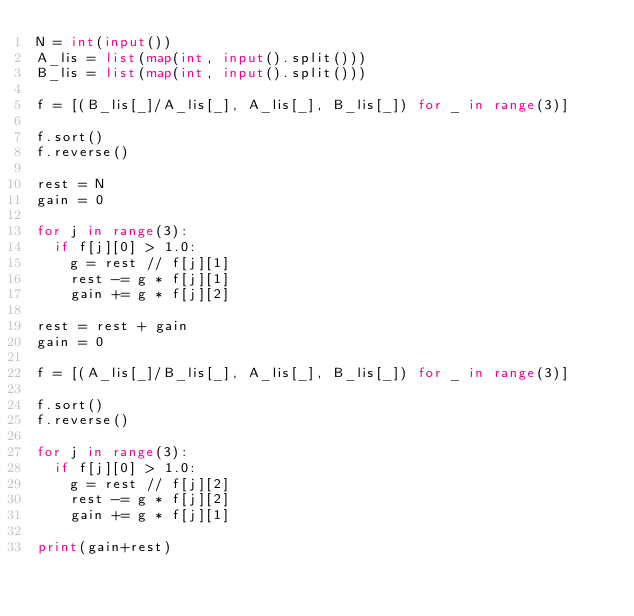<code> <loc_0><loc_0><loc_500><loc_500><_Python_>N = int(input())
A_lis = list(map(int, input().split()))
B_lis = list(map(int, input().split()))

f = [(B_lis[_]/A_lis[_], A_lis[_], B_lis[_]) for _ in range(3)]

f.sort()
f.reverse()

rest = N
gain = 0

for j in range(3):
  if f[j][0] > 1.0:
    g = rest // f[j][1]
    rest -= g * f[j][1]
    gain += g * f[j][2]

rest = rest + gain
gain = 0
    
f = [(A_lis[_]/B_lis[_], A_lis[_], B_lis[_]) for _ in range(3)]

f.sort()
f.reverse()

for j in range(3):
  if f[j][0] > 1.0:
    g = rest // f[j][2]
    rest -= g * f[j][2]
    gain += g * f[j][1]

print(gain+rest)</code> 